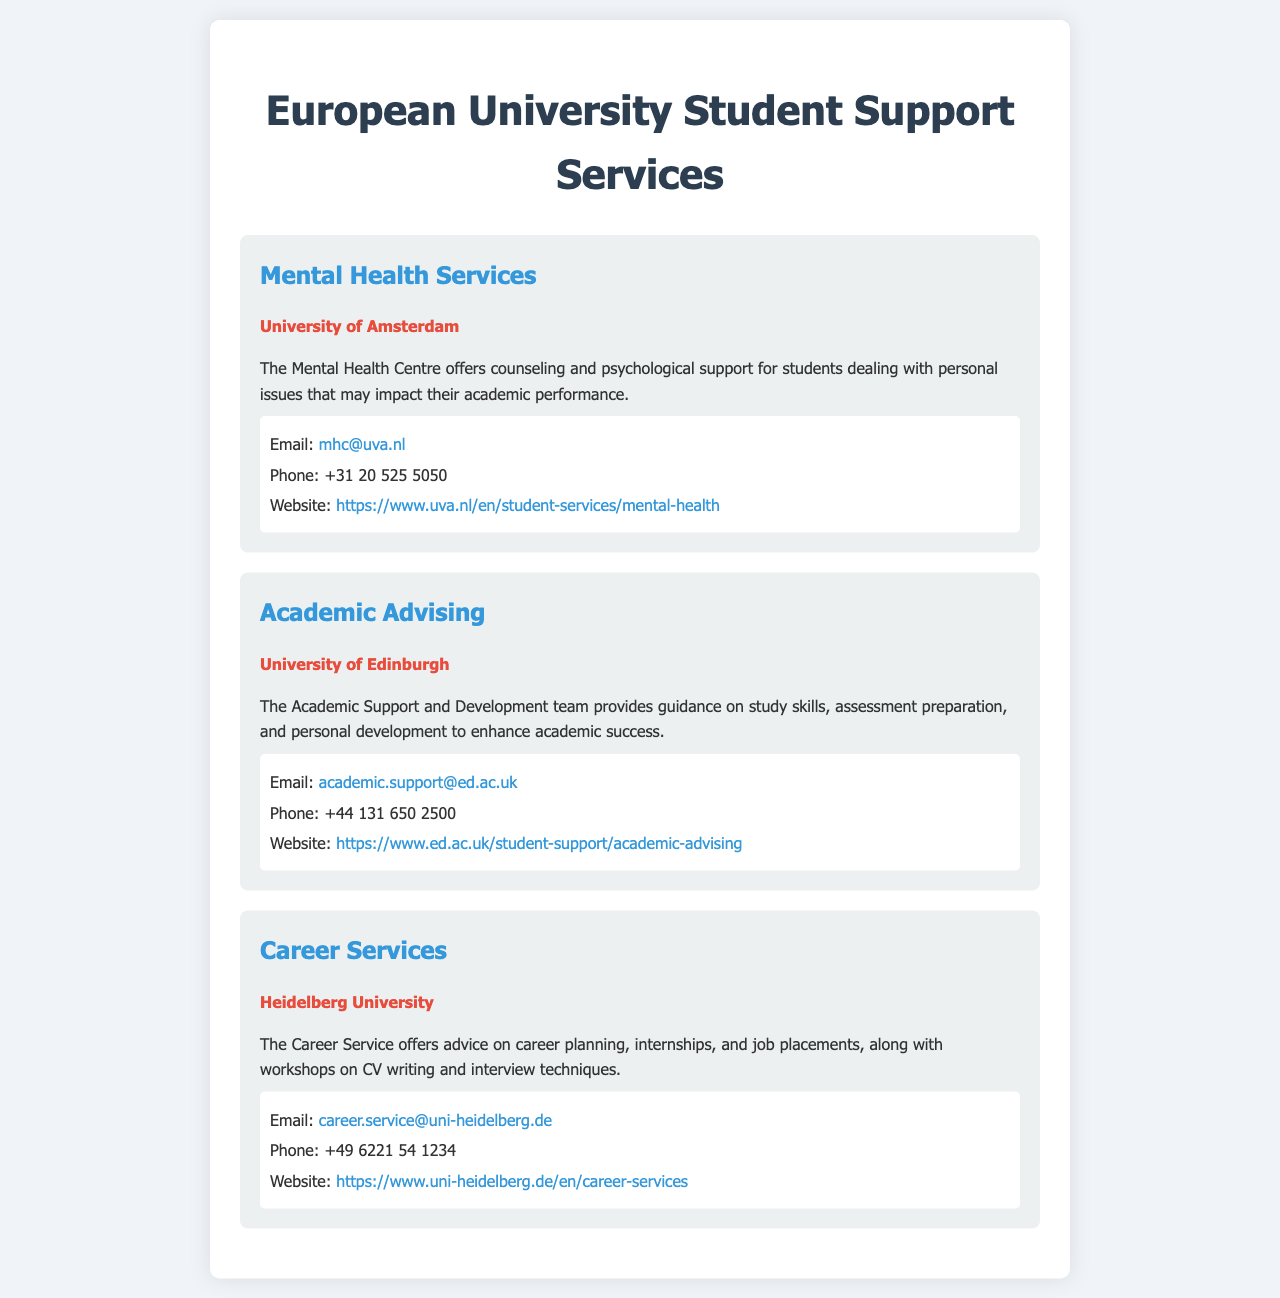what services does the University of Amsterdam offer? The University of Amsterdam offers Mental Health Services which provide counseling and psychological support for students.
Answer: Mental Health Services what is the email address for academic advising at the University of Edinburgh? The email address for academic advising at the University of Edinburgh is provided in the contact information section under the Academic Advising service.
Answer: academic.support@ed.ac.uk how can students at Heidelberg University get help with career planning? Heidelberg University offers Career Services which provide advice on career planning, internships, and job placements.
Answer: Career Services what is the phone number for mental health services at the University of Amsterdam? The phone number is listed in the contact information for the Mental Health Services section of the document.
Answer: +31 20 525 5050 which university provides workshops on CV writing? The university that provides workshops on CV writing is mentioned in the Career Services section.
Answer: Heidelberg University what is the website for academic advising at the University of Edinburgh? The website link for academic advising can be found in the contact information of the Academic Advising service.
Answer: https://www.ed.ac.uk/student-support/academic-advising who offers psychological support for personal issues? The service that offers psychological support for personal issues is detailed in the Mental Health Services section.
Answer: University of Amsterdam how many services are listed in the document? The document lists a total of three distinct services offered at different universities.
Answer: 3 